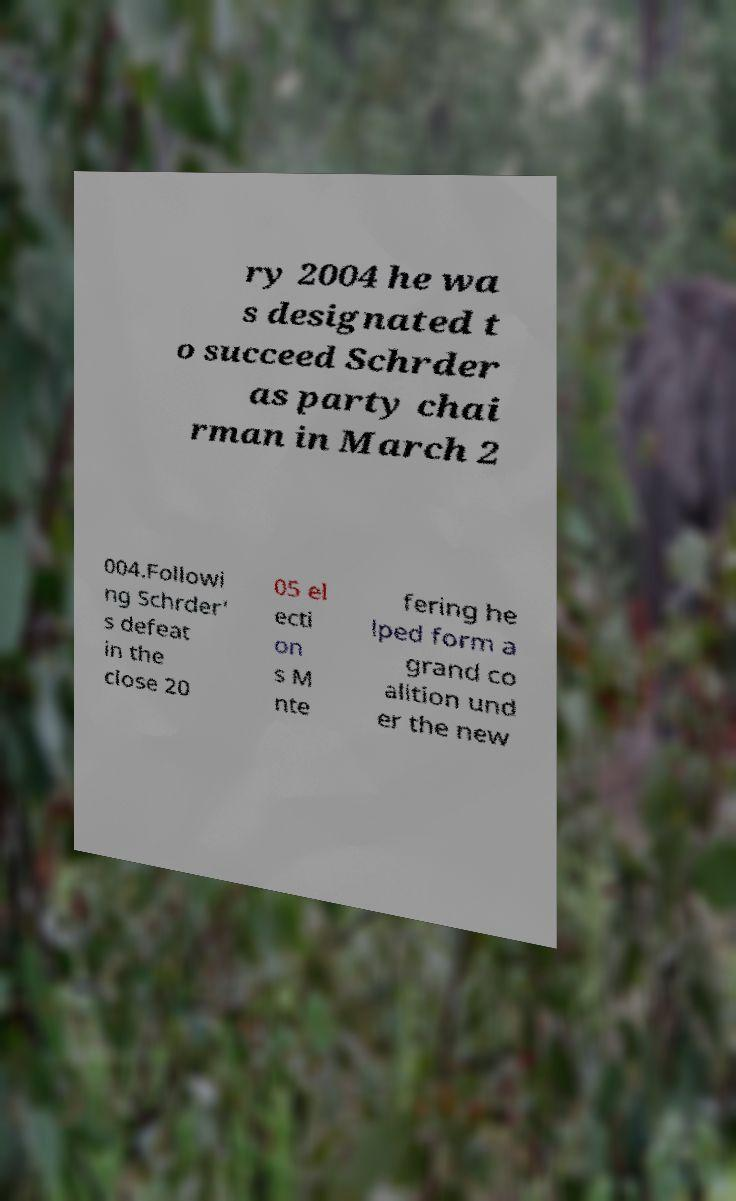Could you assist in decoding the text presented in this image and type it out clearly? ry 2004 he wa s designated t o succeed Schrder as party chai rman in March 2 004.Followi ng Schrder' s defeat in the close 20 05 el ecti on s M nte fering he lped form a grand co alition und er the new 